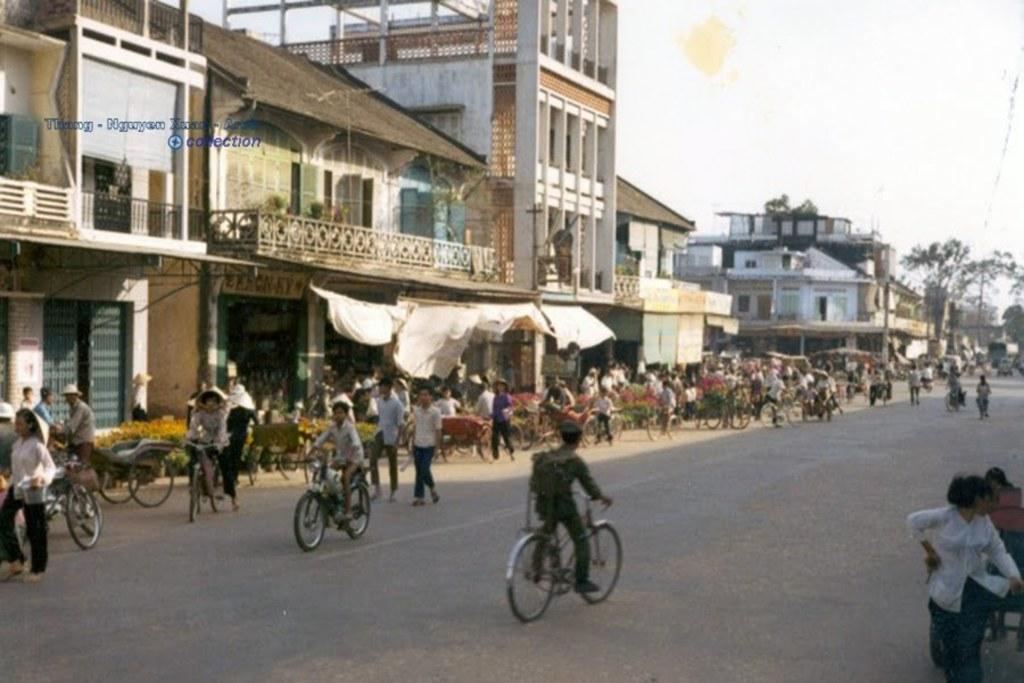What can be seen beside the road in the image? There are stalls beside the road in the image. What is happening on the road in the image? Many vehicles are moving on the road in the image. What is visible behind the stalls in the image? There are buildings visible behind the stalls in the image. What type of vegetation is on the right side of the image? There is a tree on the right side of the image. How many lizards are sitting on the tree in the image? There are no lizards present in the image; it features a tree on the right side of the image. Who is the creator of the vehicles moving on the road in the image? The creator of the vehicles cannot be determined from the image; it only shows the vehicles in motion. 